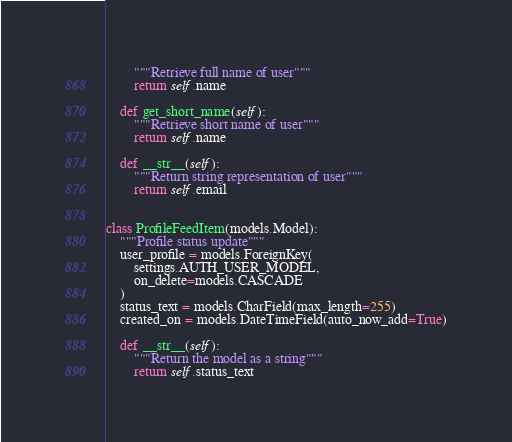Convert code to text. <code><loc_0><loc_0><loc_500><loc_500><_Python_>        """Retrieve full name of user"""
        return self.name

    def get_short_name(self):
        """Retrieve short name of user"""
        return self.name

    def __str__(self):
        """Return string representation of user"""
        return self.email


class ProfileFeedItem(models.Model):
    """Profile status update"""
    user_profile = models.ForeignKey(
        settings.AUTH_USER_MODEL,
        on_delete=models.CASCADE
    )
    status_text = models.CharField(max_length=255)
    created_on = models.DateTimeField(auto_now_add=True)

    def __str__(self):
        """Return the model as a string"""
        return self.status_text
</code> 